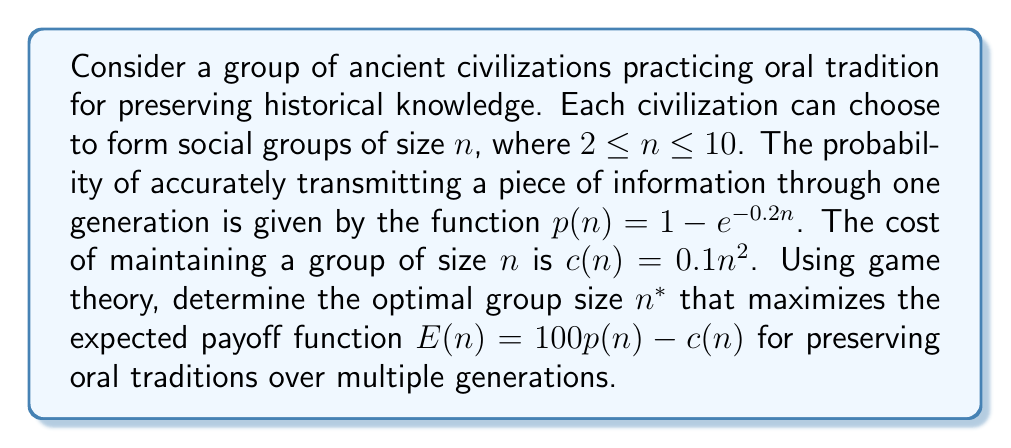Provide a solution to this math problem. To solve this problem, we'll follow these steps:

1) First, let's define our payoff function $E(n)$:
   
   $E(n) = 100p(n) - c(n)$

2) Substitute the given functions for $p(n)$ and $c(n)$:
   
   $E(n) = 100(1 - e^{-0.2n}) - 0.1n^2$

3) To find the optimal group size, we need to maximize $E(n)$. In game theory, this is typically done by finding the value of $n$ where the derivative of $E(n)$ equals zero.

4) Let's calculate the derivative of $E(n)$:
   
   $$\frac{dE}{dn} = 100(0.2e^{-0.2n}) - 0.2n$$

5) Set this equal to zero and solve for $n$:
   
   $20e^{-0.2n} - 0.2n = 0$

6) This equation cannot be solved algebraically. We need to use numerical methods or graphical analysis to find the solution.

7) Using a graphing calculator or computer software, we can plot the function:
   
   $f(n) = 20e^{-0.2n} - 0.2n$

8) The zero of this function occurs at approximately $n = 4.6$.

9) Since $n$ must be an integer in our problem, we should check the values of $E(n)$ for $n = 4$ and $n = 5$:

   $E(4) = 100(1 - e^{-0.8}) - 0.1(4^2) = 55.1$
   $E(5) = 100(1 - e^{-1.0}) - 0.1(5^2) = 55.7$

10) Therefore, the optimal integer group size is 5.
Answer: The optimal group size for preserving oral traditions is $n^* = 5$. 